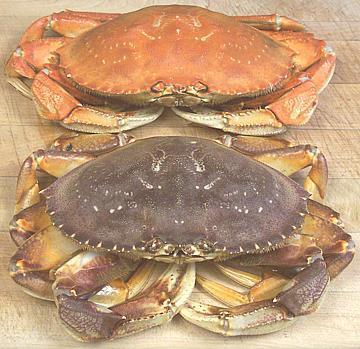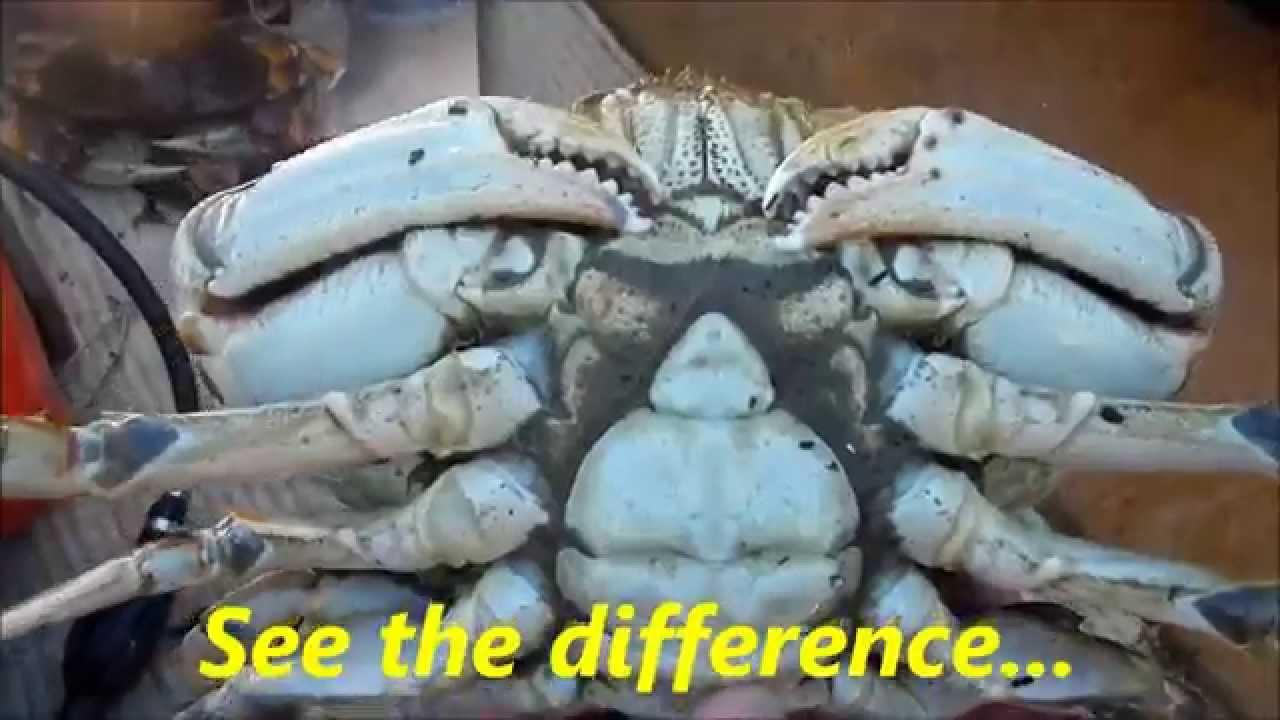The first image is the image on the left, the second image is the image on the right. Considering the images on both sides, is "There are two crabs next to each other." valid? Answer yes or no. Yes. The first image is the image on the left, the second image is the image on the right. Assess this claim about the two images: "No image contains more than two crabs, and no image features crabs that are prepared for eating.". Correct or not? Answer yes or no. Yes. 